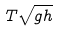Convert formula to latex. <formula><loc_0><loc_0><loc_500><loc_500>T { \sqrt { g h } }</formula> 